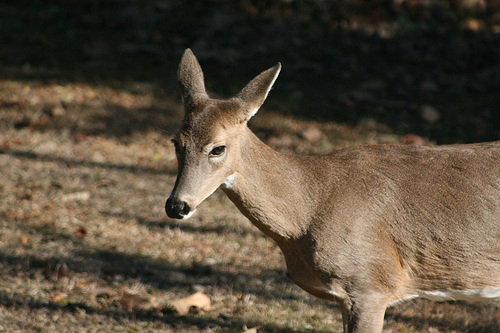<image>
Can you confirm if the deer is on the ground? Yes. Looking at the image, I can see the deer is positioned on top of the ground, with the ground providing support. 